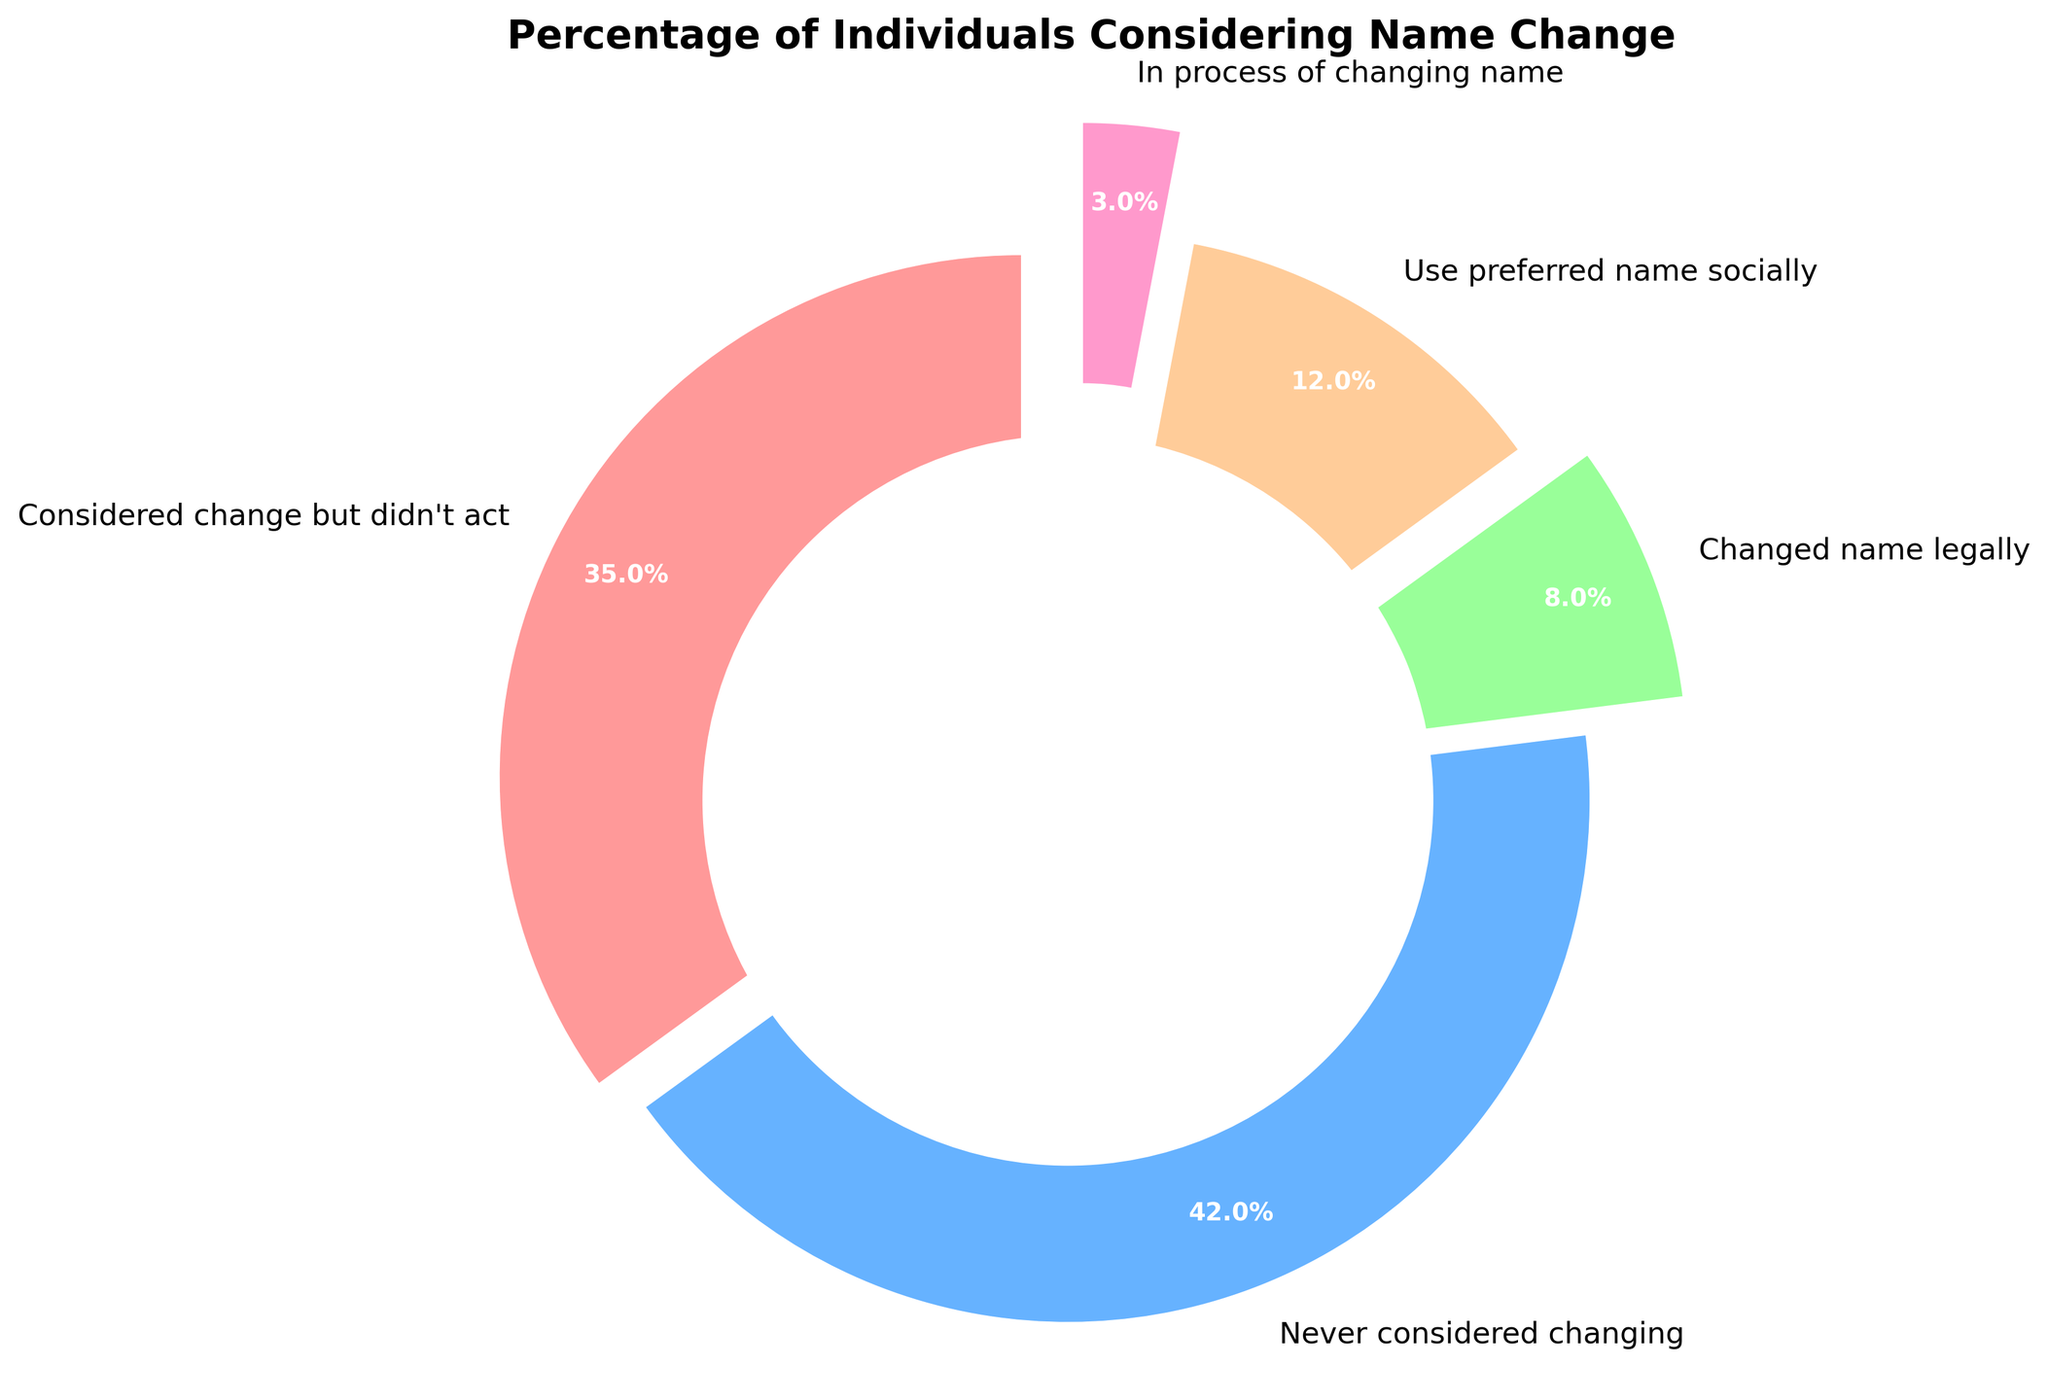Which category has the highest percentage? By looking at the pie chart, you can see that the category with the largest slice represents the highest percentage. The label shows 42% for "Never considered changing".
Answer: Never considered changing Which category has the lowest percentage? The smallest slice in the pie chart represents the category with the lowest percentage. The label shows 3% for "In process of changing name".
Answer: In process of changing name What is the combined percentage of individuals who have either changed their name legally or are in the process of changing it? To find the combined percentage, add the percentages for "Changed name legally" and "In process of changing name". The values are 8% and 3% respectively. So, 8% + 3% = 11%.
Answer: 11% What is the difference in percentage between those who never considered changing their name and those who use a preferred name socially? Subtract the percentage of those who use a preferred name socially (12%) from those who never considered changing their name (42%). So, 42% - 12% = 30%.
Answer: 30% Which category has a higher percentage: "Considered change but didn't act" or "Use preferred name socially"? By comparing the sizes of the slices or the labels, you can see that "Considered change but didn't act" (35%) has a higher percentage than "Use preferred name socially" (12%).
Answer: Considered change but didn't act What percentage of individuals have considered changing their name (including all relevant categories)? To find the percentage of individuals who have considered changing their name in any context, add the percentages of all relevant categories: "Considered change but didn't act" (35%), "Changed name legally" (8%), "Use preferred name socially" (12%), and "In process of changing name" (3%). So, 35% + 8% + 12% + 3% = 58%.
Answer: 58% Is the percentage of individuals who never considered changing their name greater than the combined percentage of individuals in the other categories? Calculate the combined percentage of the other categories: "Considered change but didn't act" (35%), "Changed name legally" (8%), "Use preferred name socially" (12%), and "In process of changing name" (3%). The total is 58%. Since 42% (never considered changing) is less than 58% (combined other categories), the answer is no.
Answer: No What is the difference between the percentage of those who considered changing but didn't act and those who changed their name legally? Subtract the percentage of those who changed their name legally (8%) from those who considered changing but didn't act (35%). So, 35% - 8% = 27%.
Answer: 27% Which two categories have similar percentages and what are they? By visually inspecting the pie chart, the categories "Changed name legally" (8%) and "In process of changing name" (3%) have distinctly different percentages, but the categories "Considered change but didn't act" (35%) and "Never considered changing" (42%) have a somewhat closer percentage difference compared to others.
Answer: Considered change but didn't act (35%) and Never considered changing (42%) 